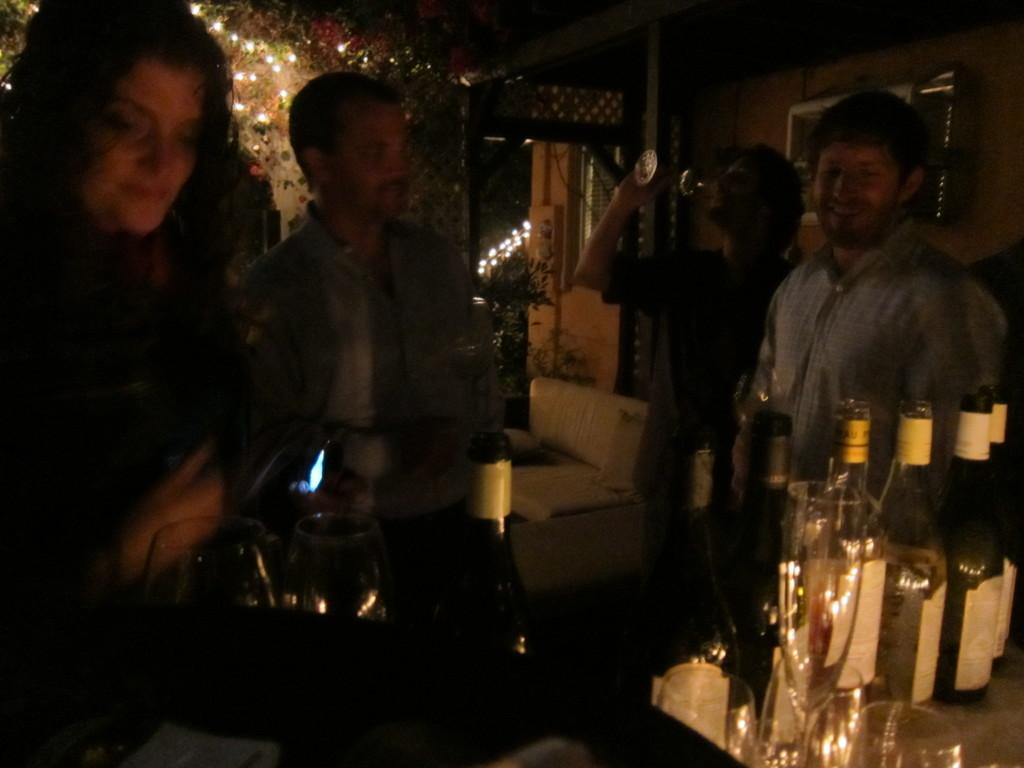What objects are on the table in the image? There are bottles on a table in the image. Where is the table located in the image? The table is located in the bottom right hand corner of the image. Can you describe the people in the image? There are people standing in the image. What type of vest is the woman wearing in the image? There is no woman present in the image, and therefore no vest to describe. 